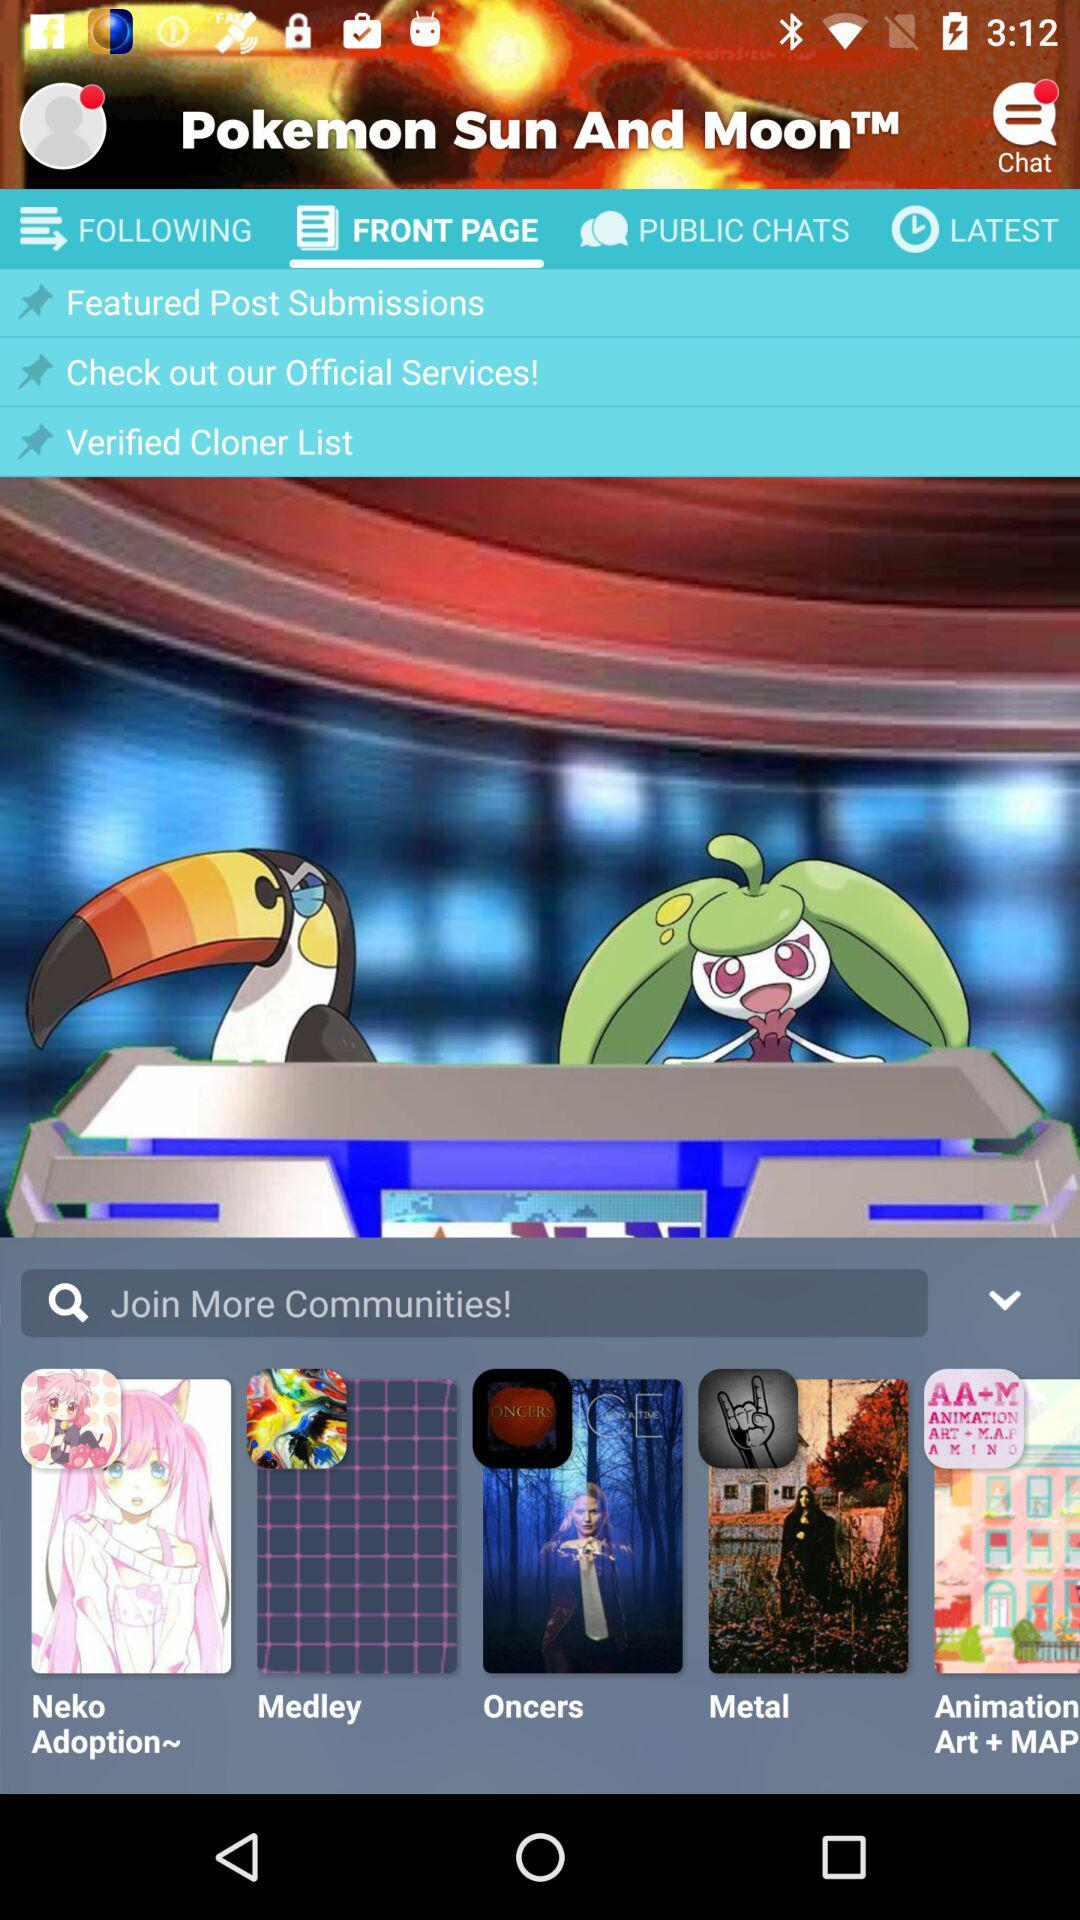What is the application name? The application name is "Pokemon Sun And Moon". 